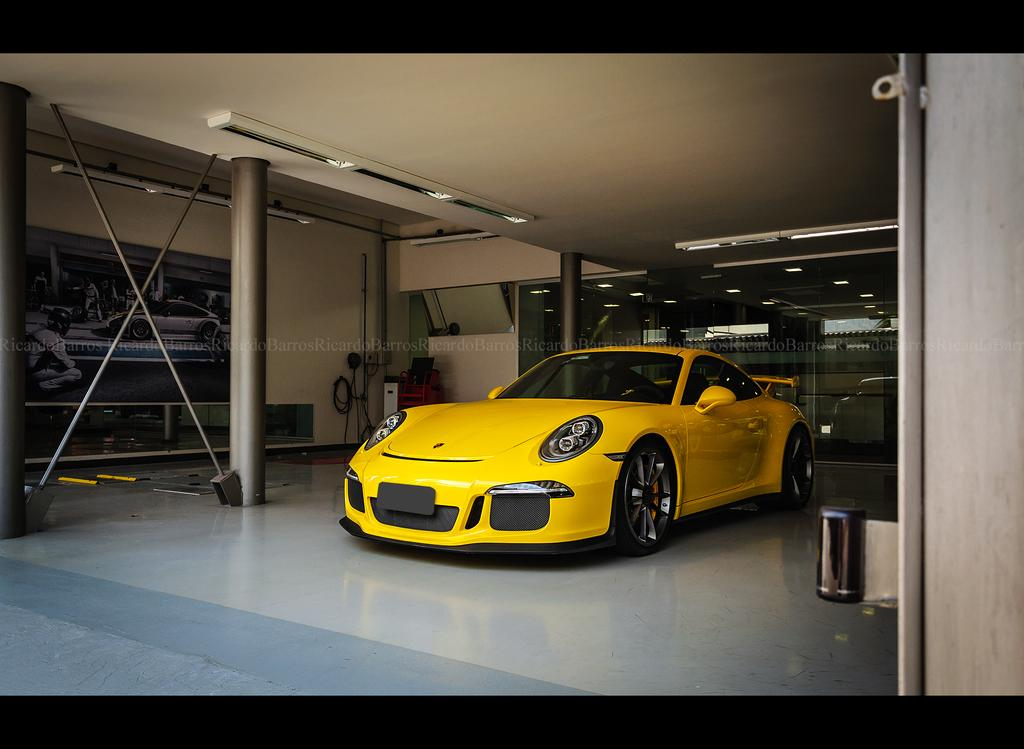What color is the car in the image? The car in the image is yellow. How is the car described in the image? The car is described as beautiful. Where is the car located in the image? The car is in the middle of the image. What is behind the car in the image? There is a glass wall behind the car. Can you tell me how many cats are sitting on the car in the image? There are no cats present in the image; it only features a yellow car. Is there a doctor standing next to the car in the image? There is no doctor present in the image; it only features a yellow car and a glass wall behind it. 